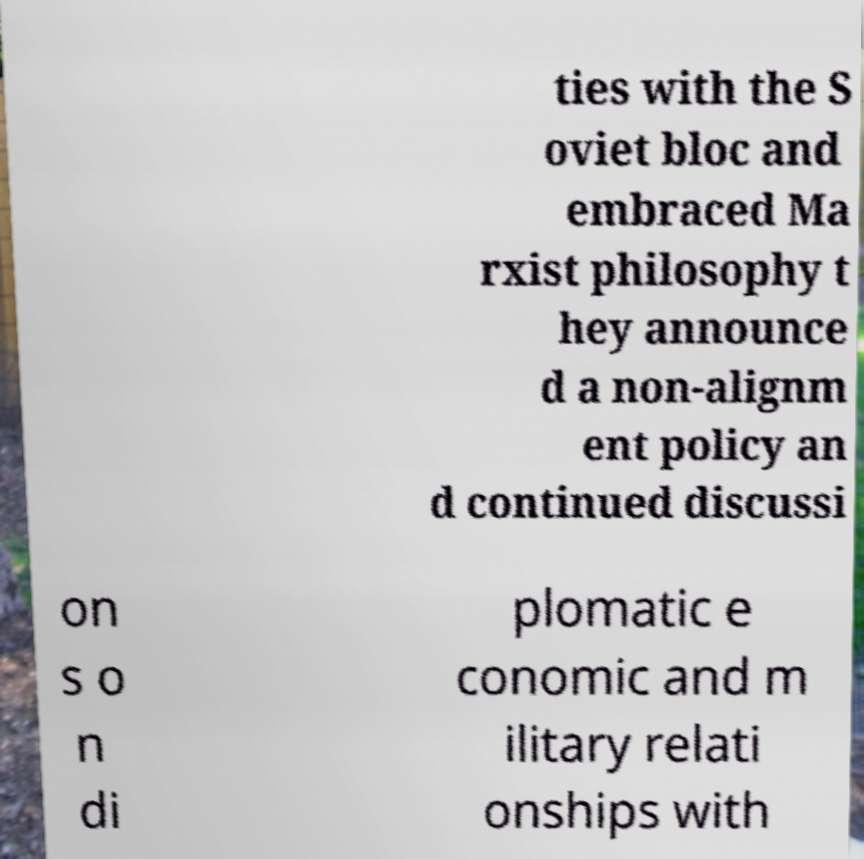There's text embedded in this image that I need extracted. Can you transcribe it verbatim? ties with the S oviet bloc and embraced Ma rxist philosophy t hey announce d a non-alignm ent policy an d continued discussi on s o n di plomatic e conomic and m ilitary relati onships with 